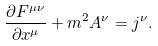Convert formula to latex. <formula><loc_0><loc_0><loc_500><loc_500>\frac { \partial F ^ { \mu \nu } } { \partial x ^ { \mu } } + m ^ { 2 } A ^ { \nu } = j ^ { \nu } .</formula> 